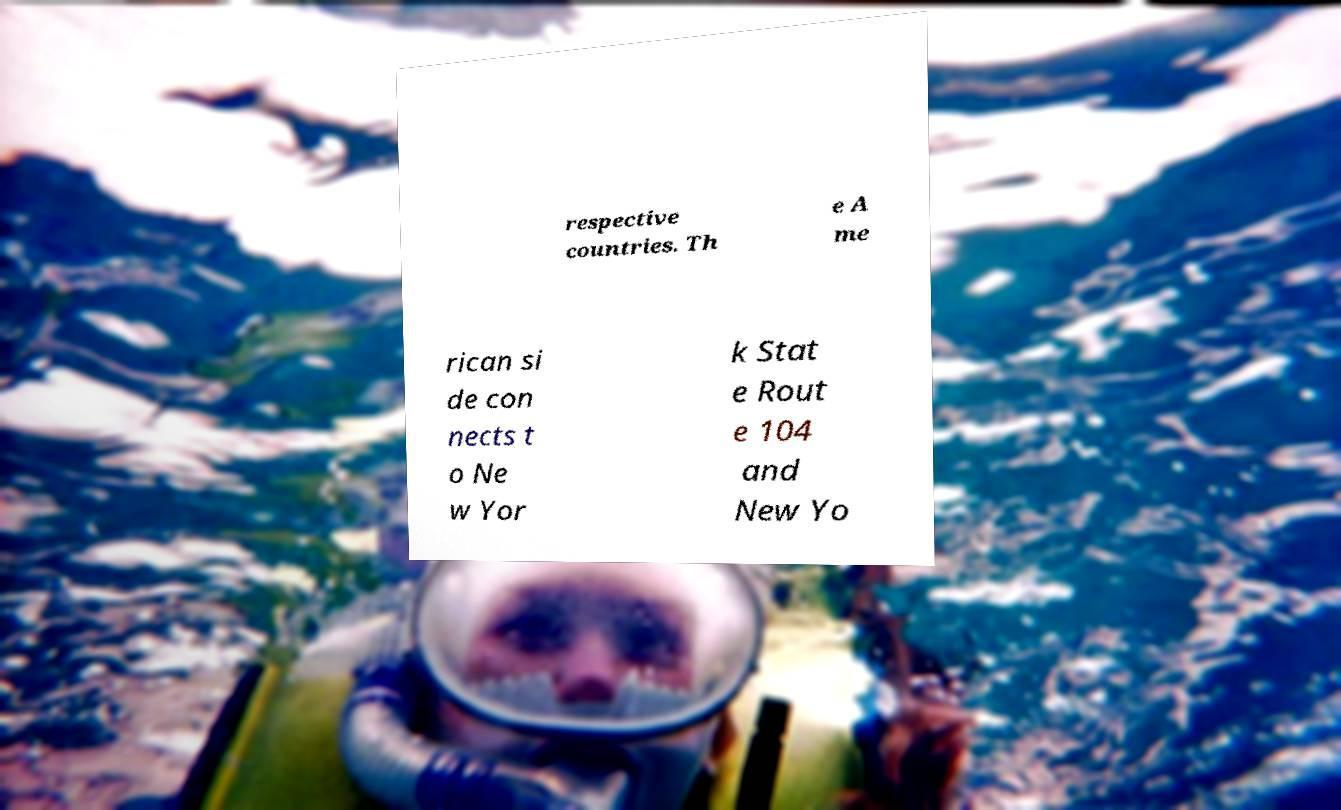What messages or text are displayed in this image? I need them in a readable, typed format. respective countries. Th e A me rican si de con nects t o Ne w Yor k Stat e Rout e 104 and New Yo 